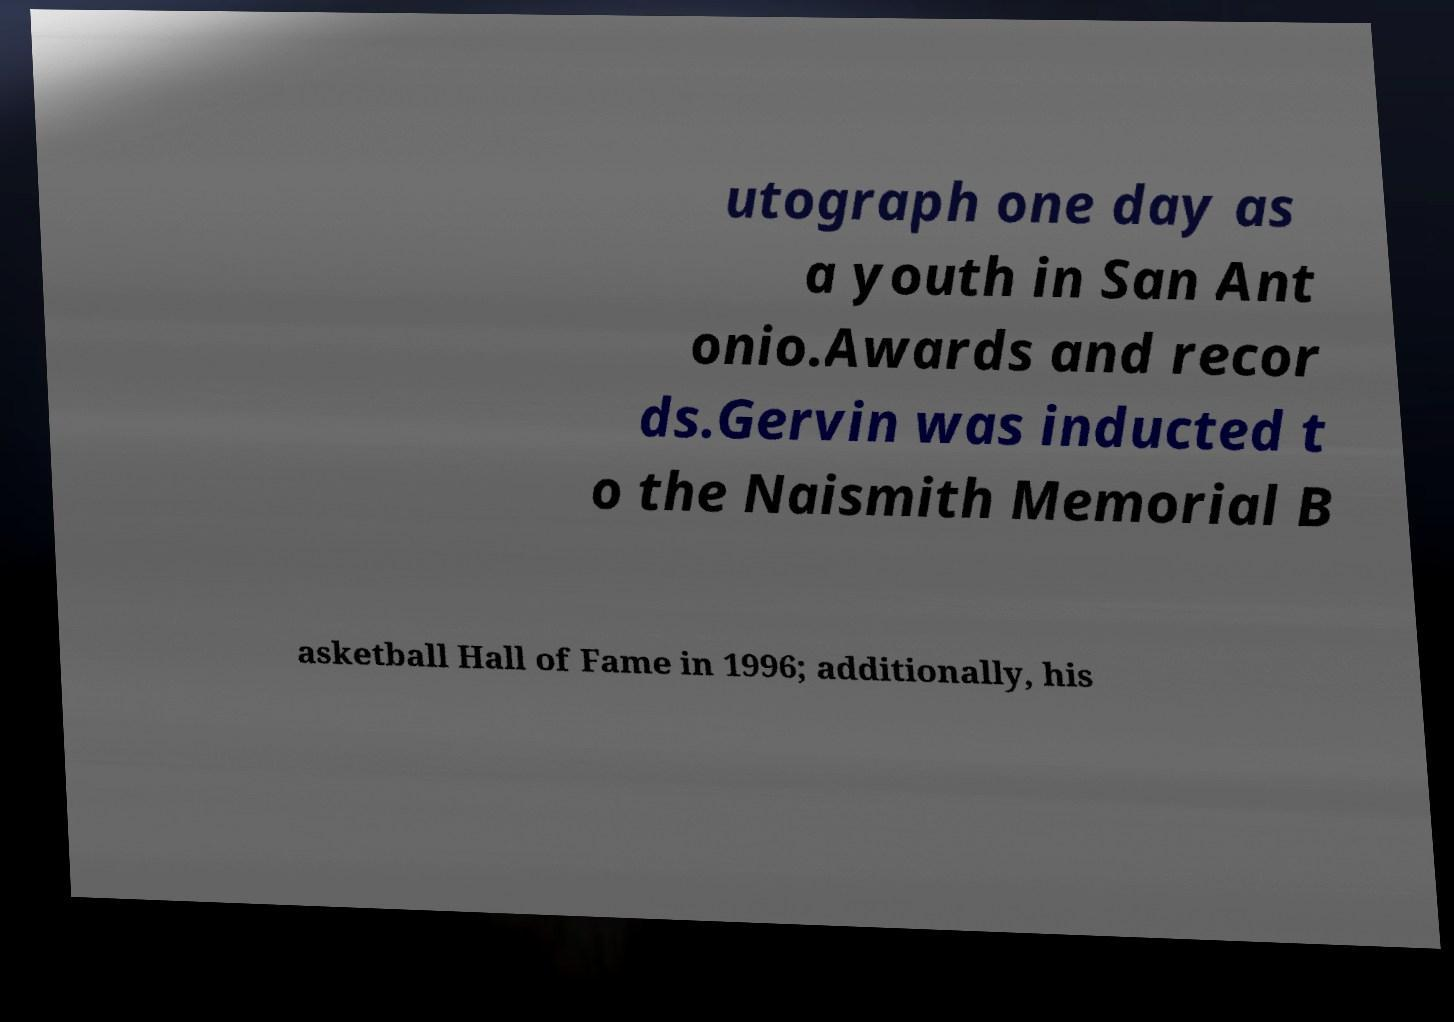Can you read and provide the text displayed in the image?This photo seems to have some interesting text. Can you extract and type it out for me? utograph one day as a youth in San Ant onio.Awards and recor ds.Gervin was inducted t o the Naismith Memorial B asketball Hall of Fame in 1996; additionally, his 